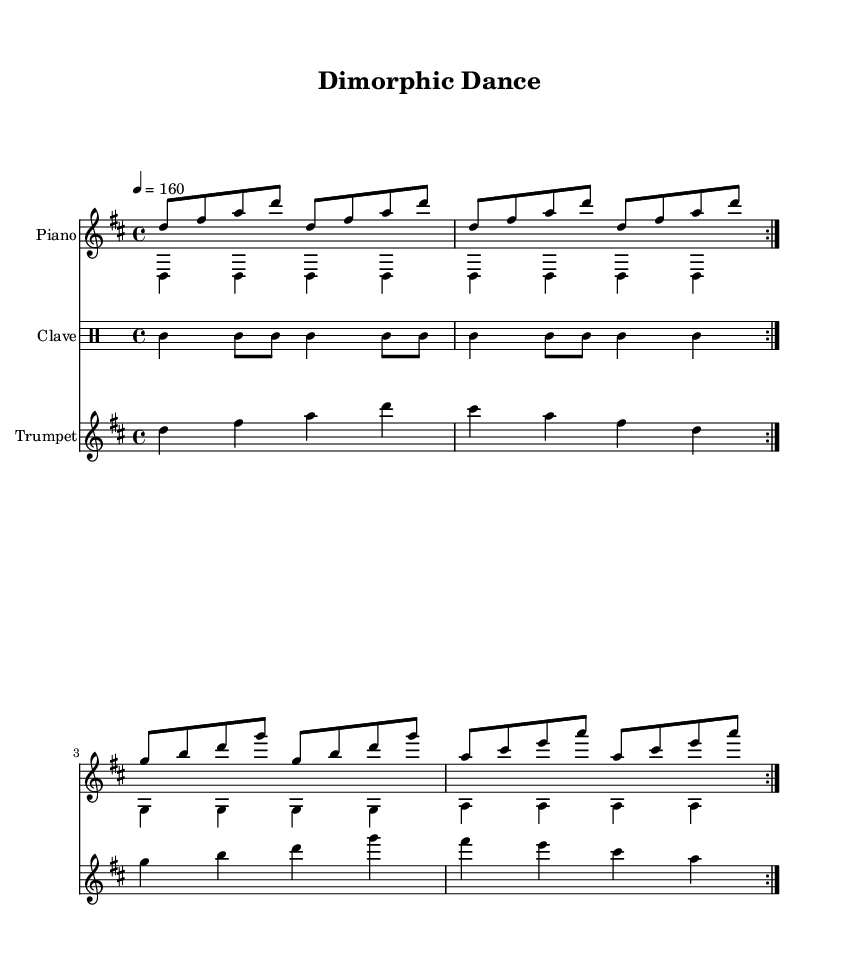What is the key signature of this music? The key signature indicates D major, which has two sharps (F# and C#). This can be determined by the presence of the sharp signs in the key signature at the beginning of the staff.
Answer: D major What is the time signature of this music? The time signature is 4/4, which can be seen at the beginning of the score. It indicates that there are four beats per measure and that the quarter note gets one beat.
Answer: 4/4 What is the tempo marking for this music? The tempo marking indicates that the piece should be played at 160 beats per minute. This is indicated by the tempo text at the beginning of the score, which states "4 = 160".
Answer: 160 How many measures are in the piano right hand part? The right hand part contains 8 measures. This can be counted by looking at the repeated volta lines and considering that each repeat includes four measures, summing up to eight.
Answer: 8 What instrument plays the melody after the introduction? The instrument that plays the melody after the introduction is the trumpet. This can be inferred from the score layout, where the trumpet staff is presented after the piano and clave staves.
Answer: Trumpet What pattern does the clave rhythm follow? The clave rhythm follows a repeating pattern that includes a combination of quarter notes and eighth notes. Specifically, it contains two measures of a rhythmic figure that alternates between quarter and eighth note durations.
Answer: Quarter and eighth notes What aspect of the composition reflects themes of sexual dimorphism in species? The composition's structure and tempo may reflect the physical and behavioral differences observed in species, which can be interpreted through variations in rhythm, syncopation, and melody typical of Latin music.
Answer: Variation in rhythm 